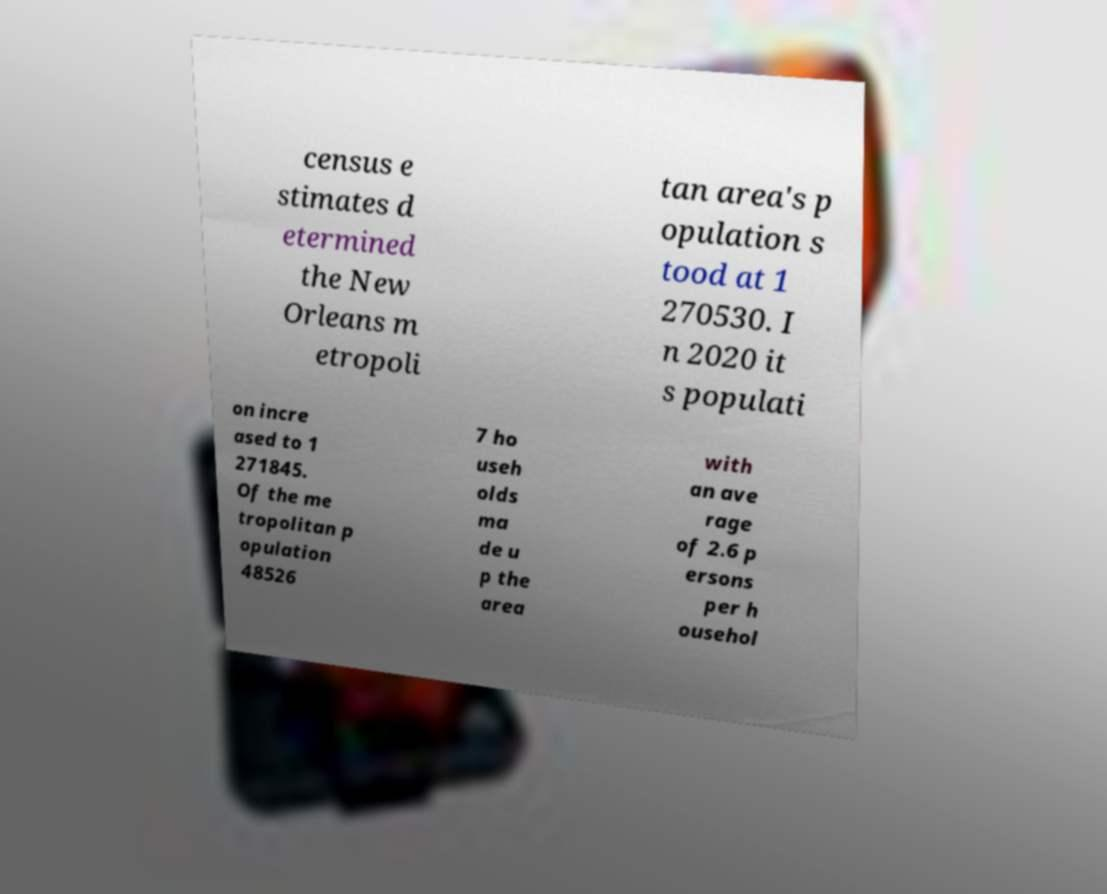There's text embedded in this image that I need extracted. Can you transcribe it verbatim? census e stimates d etermined the New Orleans m etropoli tan area's p opulation s tood at 1 270530. I n 2020 it s populati on incre ased to 1 271845. Of the me tropolitan p opulation 48526 7 ho useh olds ma de u p the area with an ave rage of 2.6 p ersons per h ousehol 